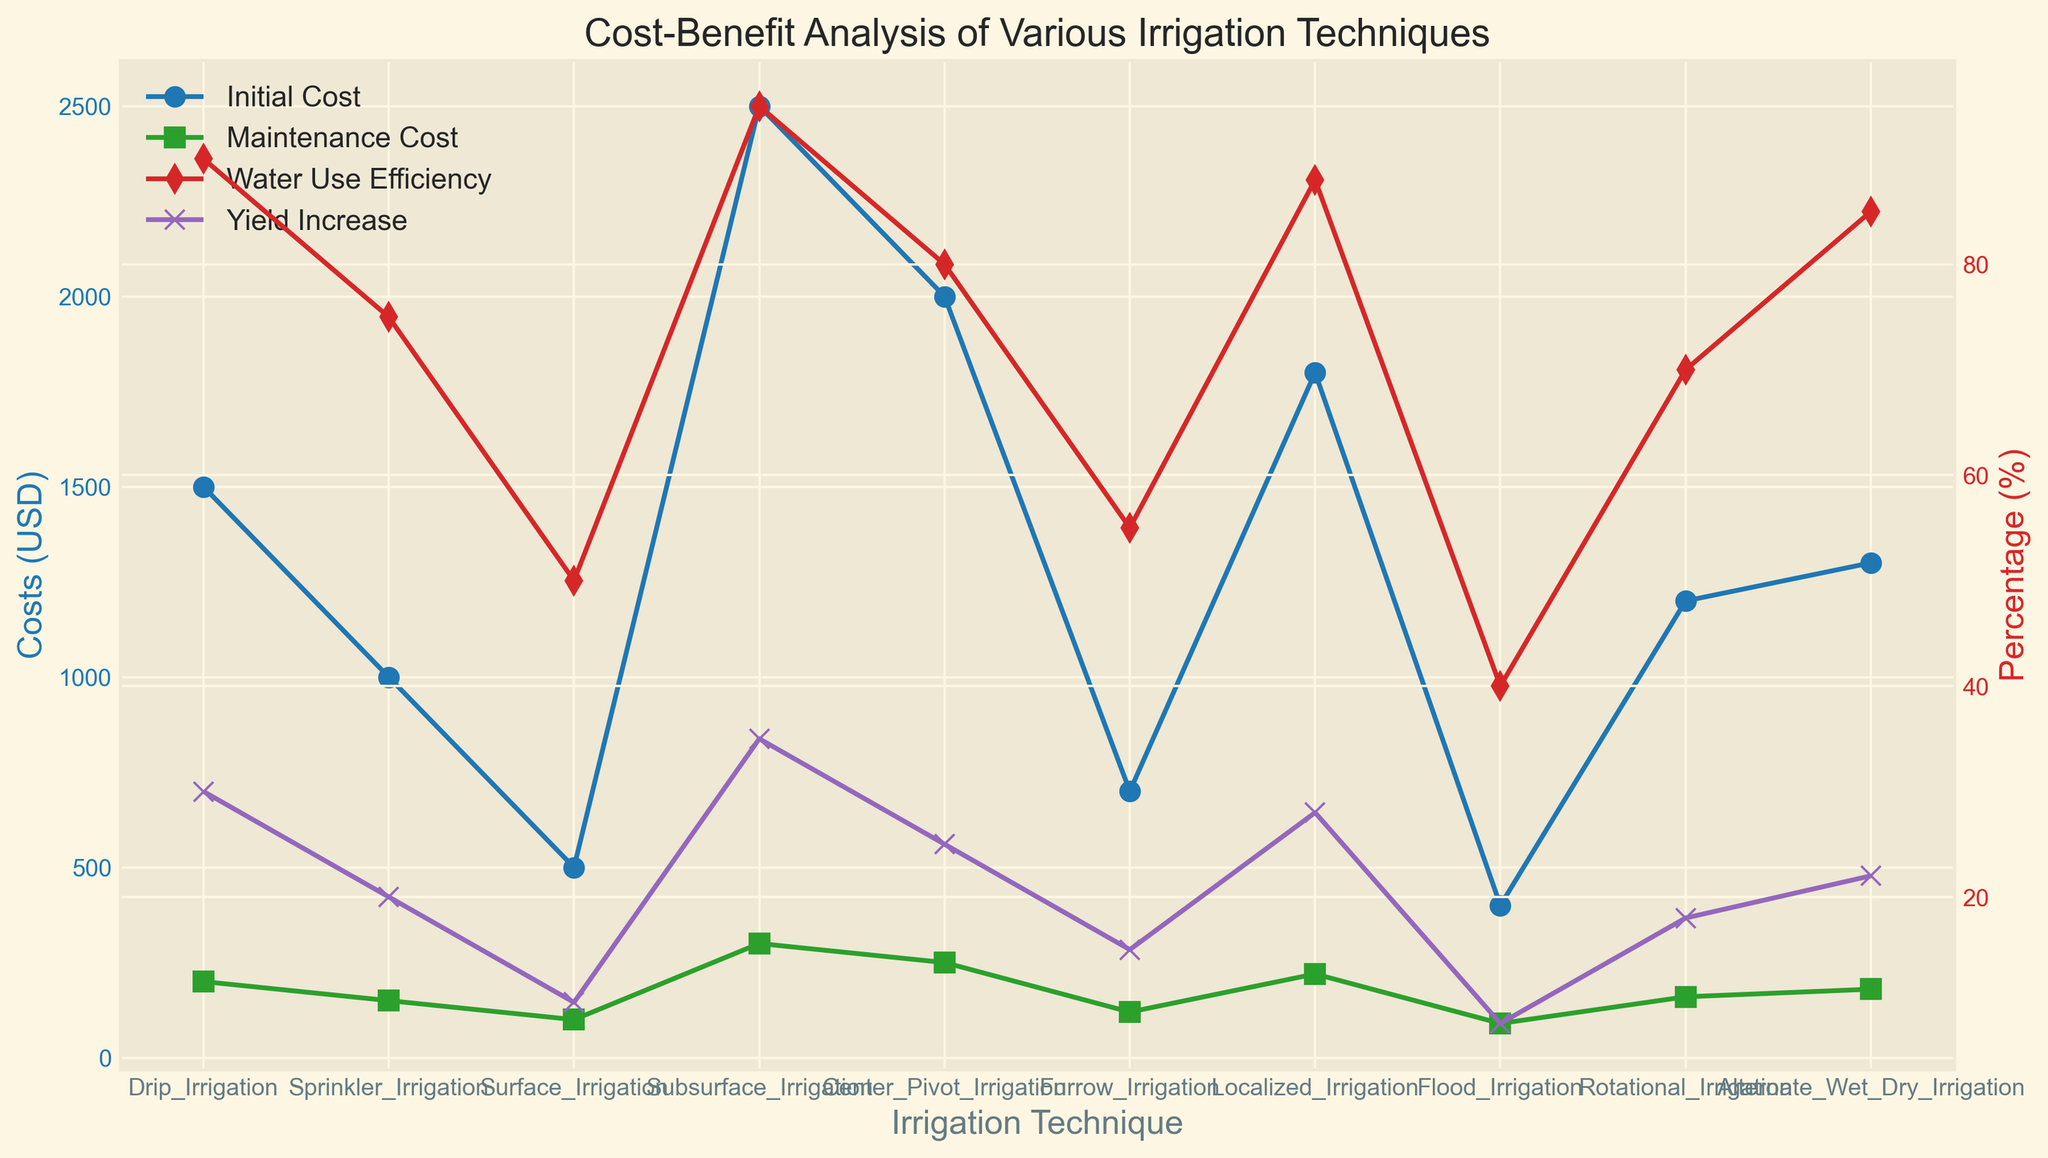Which irrigation technique has the highest initial cost? The plot shows the initial cost values for each irrigation technique. The highest initial cost is represented by the highest peak of the blue line.
Answer: Subsurface Irrigation Which irrigation technique exhibits the lowest water use efficiency? The plot with red markers indicates water use efficiency for various irrigation techniques. The lowest value on this line corresponds to the technique in question.
Answer: Flood Irrigation What is the average maintenance cost for all the irrigation techniques? Sum up all the maintenance cost values represented by the green line and divide by the number of techniques (10). (200 + 150 + 100 + 300 + 250 + 120 + 220 + 90 + 160 + 180) / 10 = 207
Answer: 207 USD Which irrigation technique has a higher yield increase percentage: Furrow Irrigation or Sprinkler Irrigation? Examine the yield increase percentages marked by purple markers for both techniques and compare their values.
Answer: Sprinkler Irrigation How much more does Drip Irrigation cost initially compared to Surface Irrigation? The initial costs for these two techniques can be compared by finding the difference between their values. (1500 USD - 500 USD) = 1000 USD
Answer: 1000 USD Which irrigation technique is most efficient in water use and what is its percentage? Find the highest point on the red-marked line (representing water use efficiency) and identify the associated technique.
Answer: Subsurface Irrigation, 95% How does the initial cost of Center Pivot Irrigation compare to that of Alternate Wet Dry Irrigation? Compare the initial costs represented by the blue markers for these two techniques to find if one is higher, lower, or equal to the other.
Answer: Center Pivot Irrigation is higher What is the yield increase percentage for Rotational Irrigation and how does it compare to Localized Irrigation? Identify the yield increase percentages for Rotational and Localized Irrigation from the purple markers and compare their values.
Answer: Rotational Irrigation is 18% and Localized Irrigation is 28% What is the total initial cost for implementing all these irrigation techniques on one hectare each? Sum up the initial cost values for all the techniques. (1500 + 1000 + 500 + 2500 + 2000 + 700 + 1800 + 400 + 1200 + 1300) USD = 12900 USD
Answer: 12900 USD Is the difference between the water use efficiency of Furrow and Flood Irrigation more significant than the difference between Center Pivot and Drip Irrigation? First, find the efficiency differences for both pairs: (55% - 40% = 15%) and (90% - 80% = 10%). Then compare these differences to determine which is larger.
Answer: Yes, the difference for Furrow and Flood is more significant 